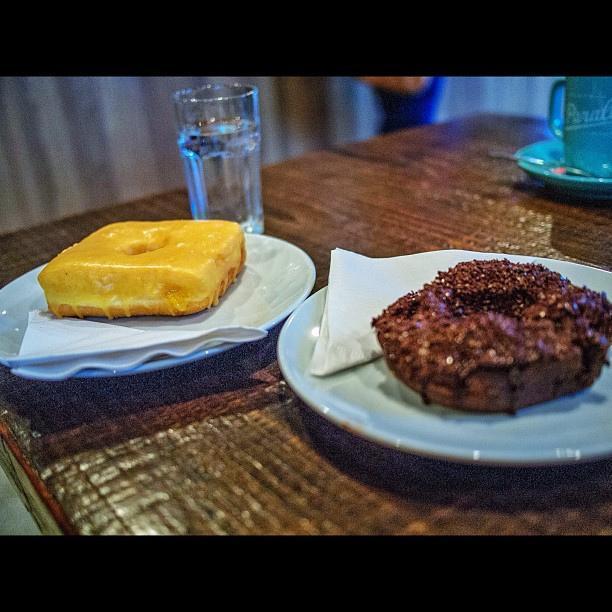How many glasses are on the table?
Give a very brief answer. 1. How many doughnuts are there?
Give a very brief answer. 2. How many plates can you see?
Give a very brief answer. 2. How many donuts are there?
Give a very brief answer. 2. 